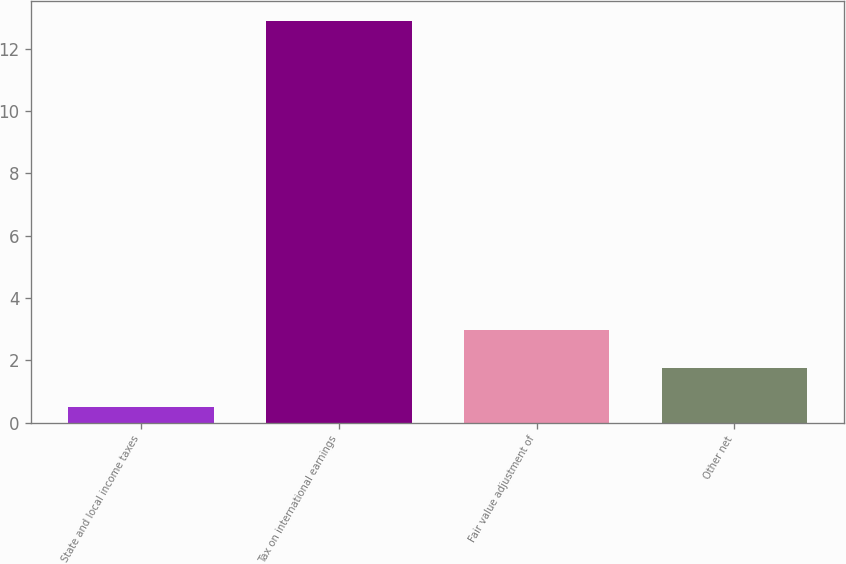Convert chart. <chart><loc_0><loc_0><loc_500><loc_500><bar_chart><fcel>State and local income taxes<fcel>Tax on international earnings<fcel>Fair value adjustment of<fcel>Other net<nl><fcel>0.5<fcel>12.9<fcel>2.98<fcel>1.74<nl></chart> 